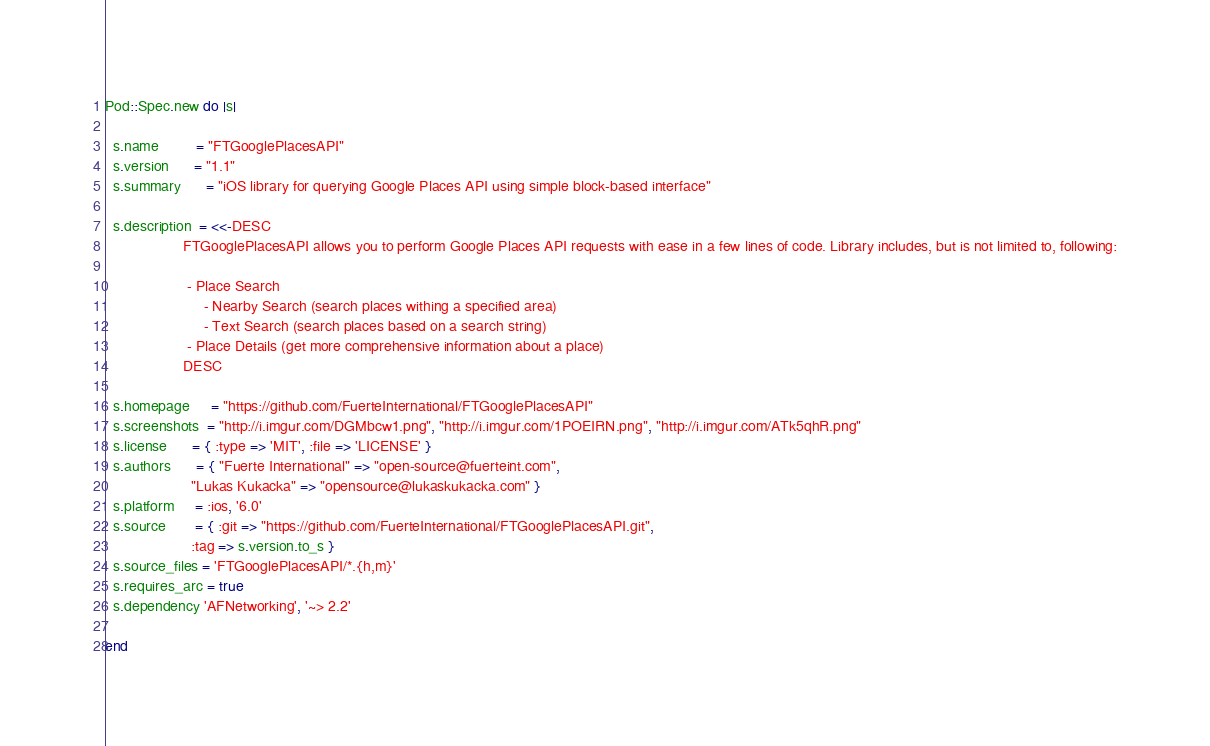Convert code to text. <code><loc_0><loc_0><loc_500><loc_500><_Ruby_>Pod::Spec.new do |s|

  s.name         = "FTGooglePlacesAPI"
  s.version      = "1.1"
  s.summary      = "iOS library for querying Google Places API using simple block-based interface"

  s.description  = <<-DESC
                   FTGooglePlacesAPI allows you to perform Google Places API requests with ease in a few lines of code. Library includes, but is not limited to, following:

				    - Place Search
				        - Nearby Search (search places withing a specified area)
				        - Text Search (search places based on a search string)
					- Place Details (get more comprehensive information about a place)
                   DESC

  s.homepage     = "https://github.com/FuerteInternational/FTGooglePlacesAPI"
  s.screenshots  = "http://i.imgur.com/DGMbcw1.png", "http://i.imgur.com/1POEIRN.png", "http://i.imgur.com/ATk5qhR.png"
  s.license      = { :type => 'MIT', :file => 'LICENSE' }
  s.authors      = { "Fuerte International" => "open-source@fuerteint.com",
                     "Lukas Kukacka" => "opensource@lukaskukacka.com" }
  s.platform     = :ios, '6.0'
  s.source       = { :git => "https://github.com/FuerteInternational/FTGooglePlacesAPI.git",
                     :tag => s.version.to_s }
  s.source_files = 'FTGooglePlacesAPI/*.{h,m}'
  s.requires_arc = true
  s.dependency 'AFNetworking', '~> 2.2'

end
</code> 